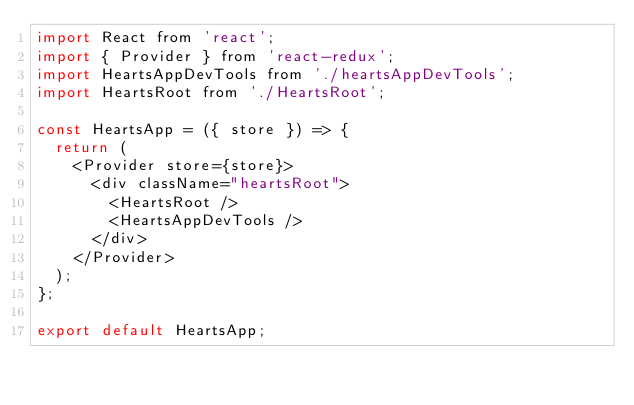<code> <loc_0><loc_0><loc_500><loc_500><_JavaScript_>import React from 'react';
import { Provider } from 'react-redux';
import HeartsAppDevTools from './heartsAppDevTools';
import HeartsRoot from './HeartsRoot';

const HeartsApp = ({ store }) => {
  return (
    <Provider store={store}>
      <div className="heartsRoot">
        <HeartsRoot />
        <HeartsAppDevTools />
      </div>
    </Provider>
  );
};

export default HeartsApp;
</code> 